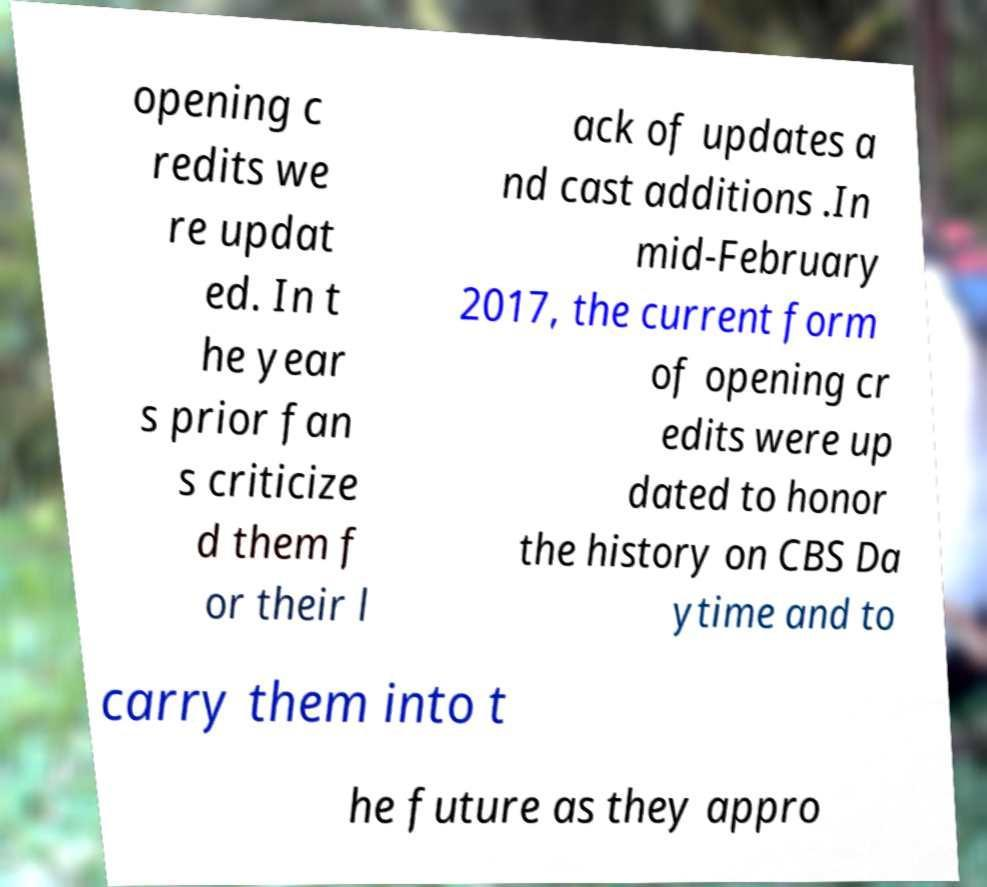Could you extract and type out the text from this image? opening c redits we re updat ed. In t he year s prior fan s criticize d them f or their l ack of updates a nd cast additions .In mid-February 2017, the current form of opening cr edits were up dated to honor the history on CBS Da ytime and to carry them into t he future as they appro 